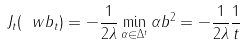<formula> <loc_0><loc_0><loc_500><loc_500>J _ { t } ( \ w b _ { t } ) = - \frac { 1 } { 2 \lambda } \min _ { \alpha \in \Delta ^ { t } } \| \alpha b \| ^ { 2 } = - \frac { 1 } { 2 \lambda } \frac { 1 } { t }</formula> 